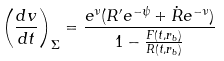<formula> <loc_0><loc_0><loc_500><loc_500>\left ( \frac { d v } { d t } \right ) _ { \Sigma } = \frac { e ^ { \nu } ( R ^ { \prime } e ^ { - \psi } + \dot { R } e ^ { - \nu } ) } { 1 - \frac { F ( t , r _ { b } ) } { R ( t , r _ { b } ) } }</formula> 